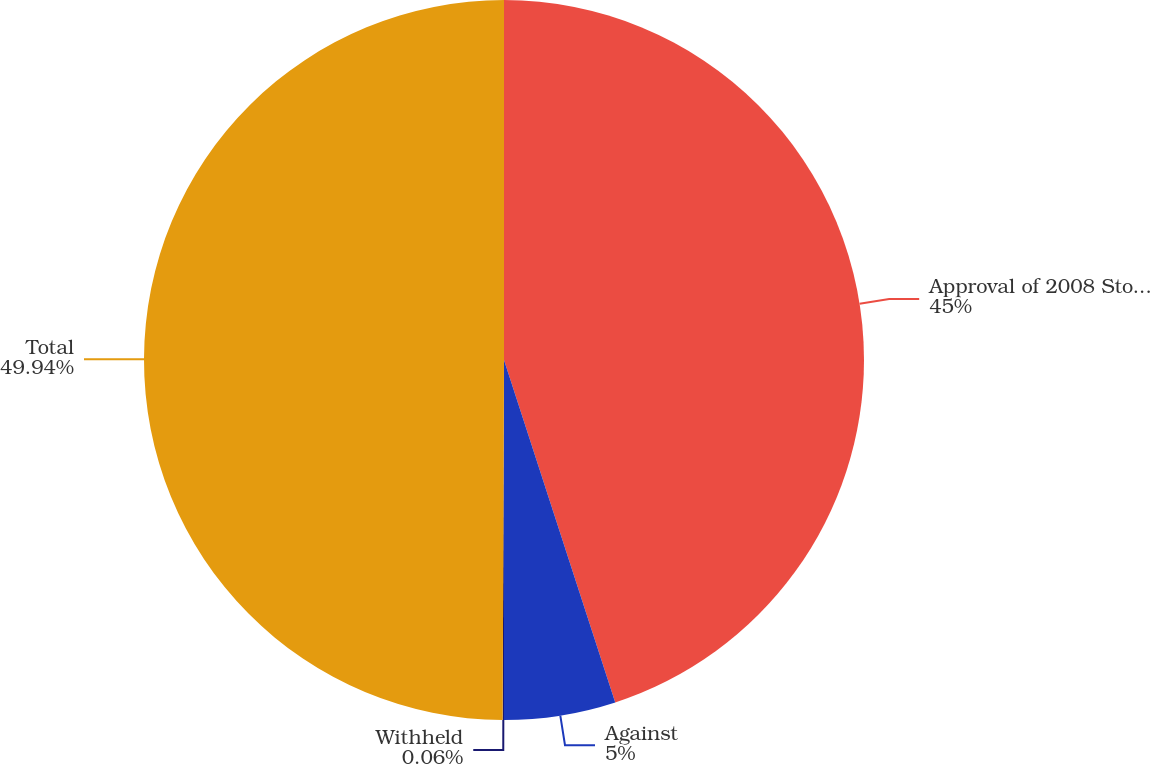Convert chart to OTSL. <chart><loc_0><loc_0><loc_500><loc_500><pie_chart><fcel>Approval of 2008 Stock Option<fcel>Against<fcel>Withheld<fcel>Total<nl><fcel>45.0%<fcel>5.0%<fcel>0.06%<fcel>49.94%<nl></chart> 